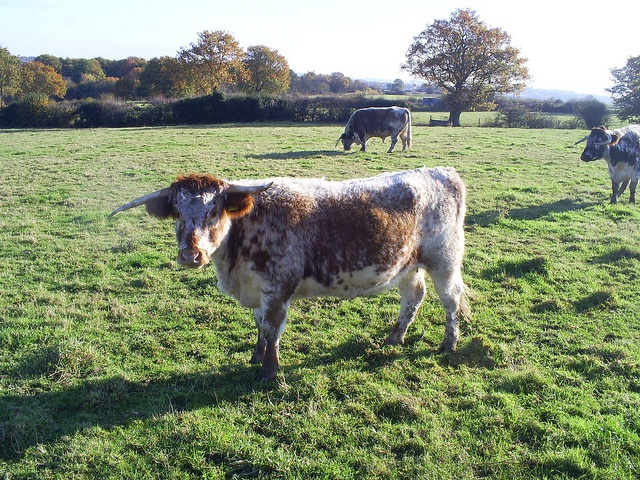Describe the objects in this image and their specific colors. I can see cow in lightblue, gray, black, white, and darkgray tones, cow in lightblue, gray, navy, and darkblue tones, and cow in lightblue, black, gray, and lightgray tones in this image. 